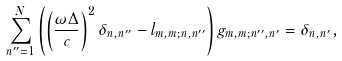Convert formula to latex. <formula><loc_0><loc_0><loc_500><loc_500>\sum _ { n ^ { \prime \prime } = 1 } ^ { N } \left ( \left ( \frac { \omega \Delta } { c } \right ) ^ { 2 } \delta _ { n , n ^ { \prime \prime } } - l _ { m , m ; n , n ^ { \prime \prime } } \right ) g _ { m , m ; n ^ { \prime \prime } , n ^ { \prime } } = \delta _ { n , n ^ { \prime } } ,</formula> 